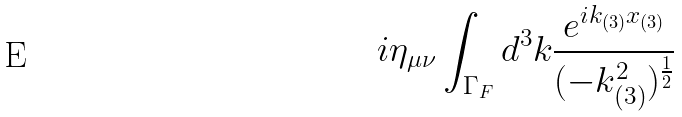<formula> <loc_0><loc_0><loc_500><loc_500>i \eta _ { \mu \nu } \int _ { \Gamma _ { F } } d ^ { 3 } k \frac { e ^ { i k _ { ( 3 ) } x _ { ( 3 ) } } } { ( - k _ { ( 3 ) } ^ { 2 } ) ^ { \frac { 1 } { 2 } } }</formula> 